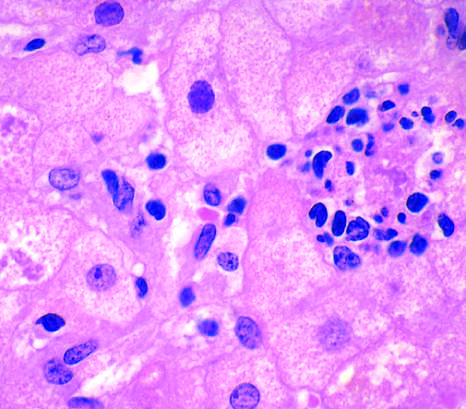s hepatocyte injury in fatty liver disease associated with chronic alcohol use?
Answer the question using a single word or phrase. Yes 